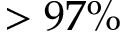<formula> <loc_0><loc_0><loc_500><loc_500>> 9 7 \%</formula> 